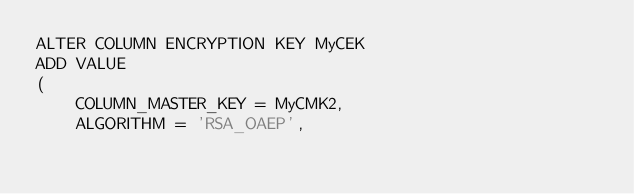<code> <loc_0><loc_0><loc_500><loc_500><_SQL_>ALTER COLUMN ENCRYPTION KEY MyCEK  
ADD VALUE  
(  
    COLUMN_MASTER_KEY = MyCMK2,   
    ALGORITHM = 'RSA_OAEP',   </code> 